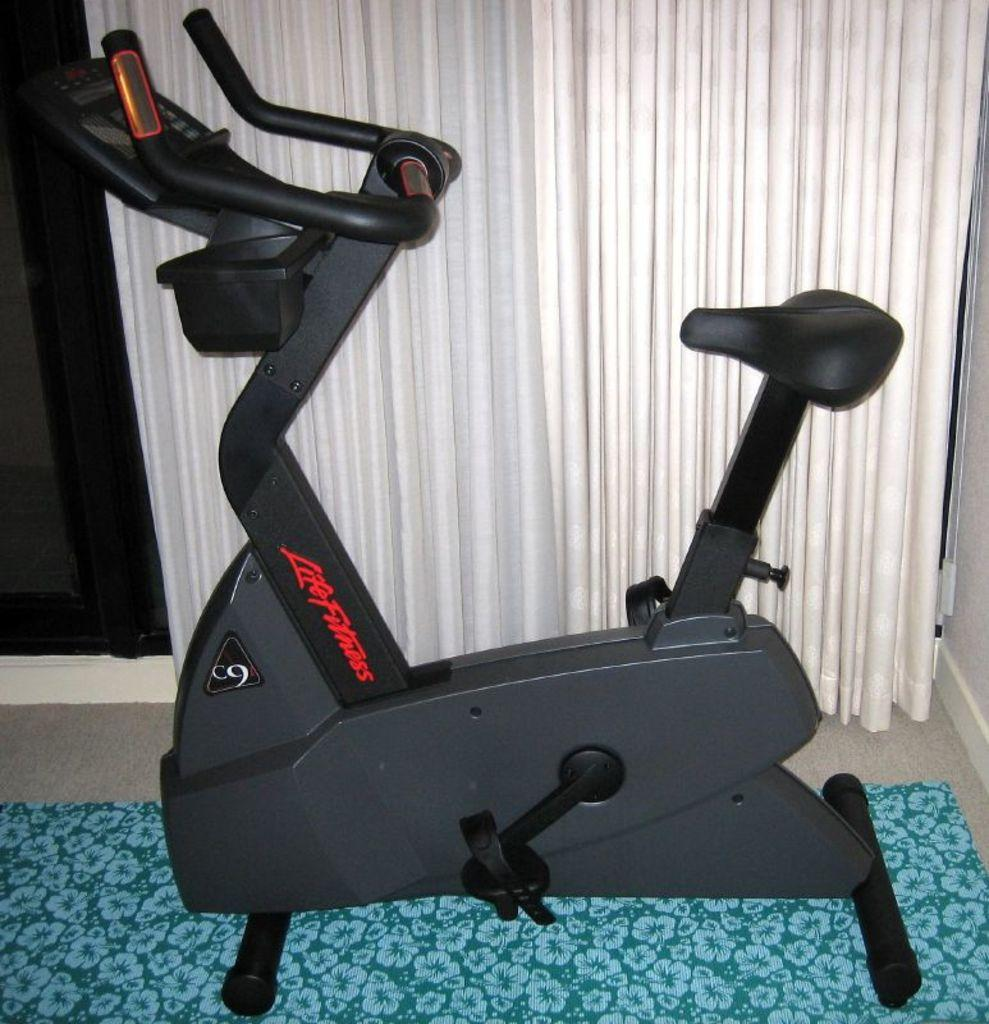What type of exercise equipment is in the image? There is a bicycle exercise machine in the image. Where is the bicycle exercise machine located? The bicycle exercise machine is on the floor. What can be seen in the background of the image? There are white curtains visible in the background of the image. What type of nerve can be seen in the image? There is no nerve present in the image; it features a bicycle exercise machine on the floor and white curtains in the background. How many beans are visible in the image? There are no beans present in the image. 